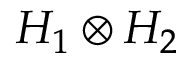Convert formula to latex. <formula><loc_0><loc_0><loc_500><loc_500>H _ { 1 } \otimes H _ { 2 }</formula> 